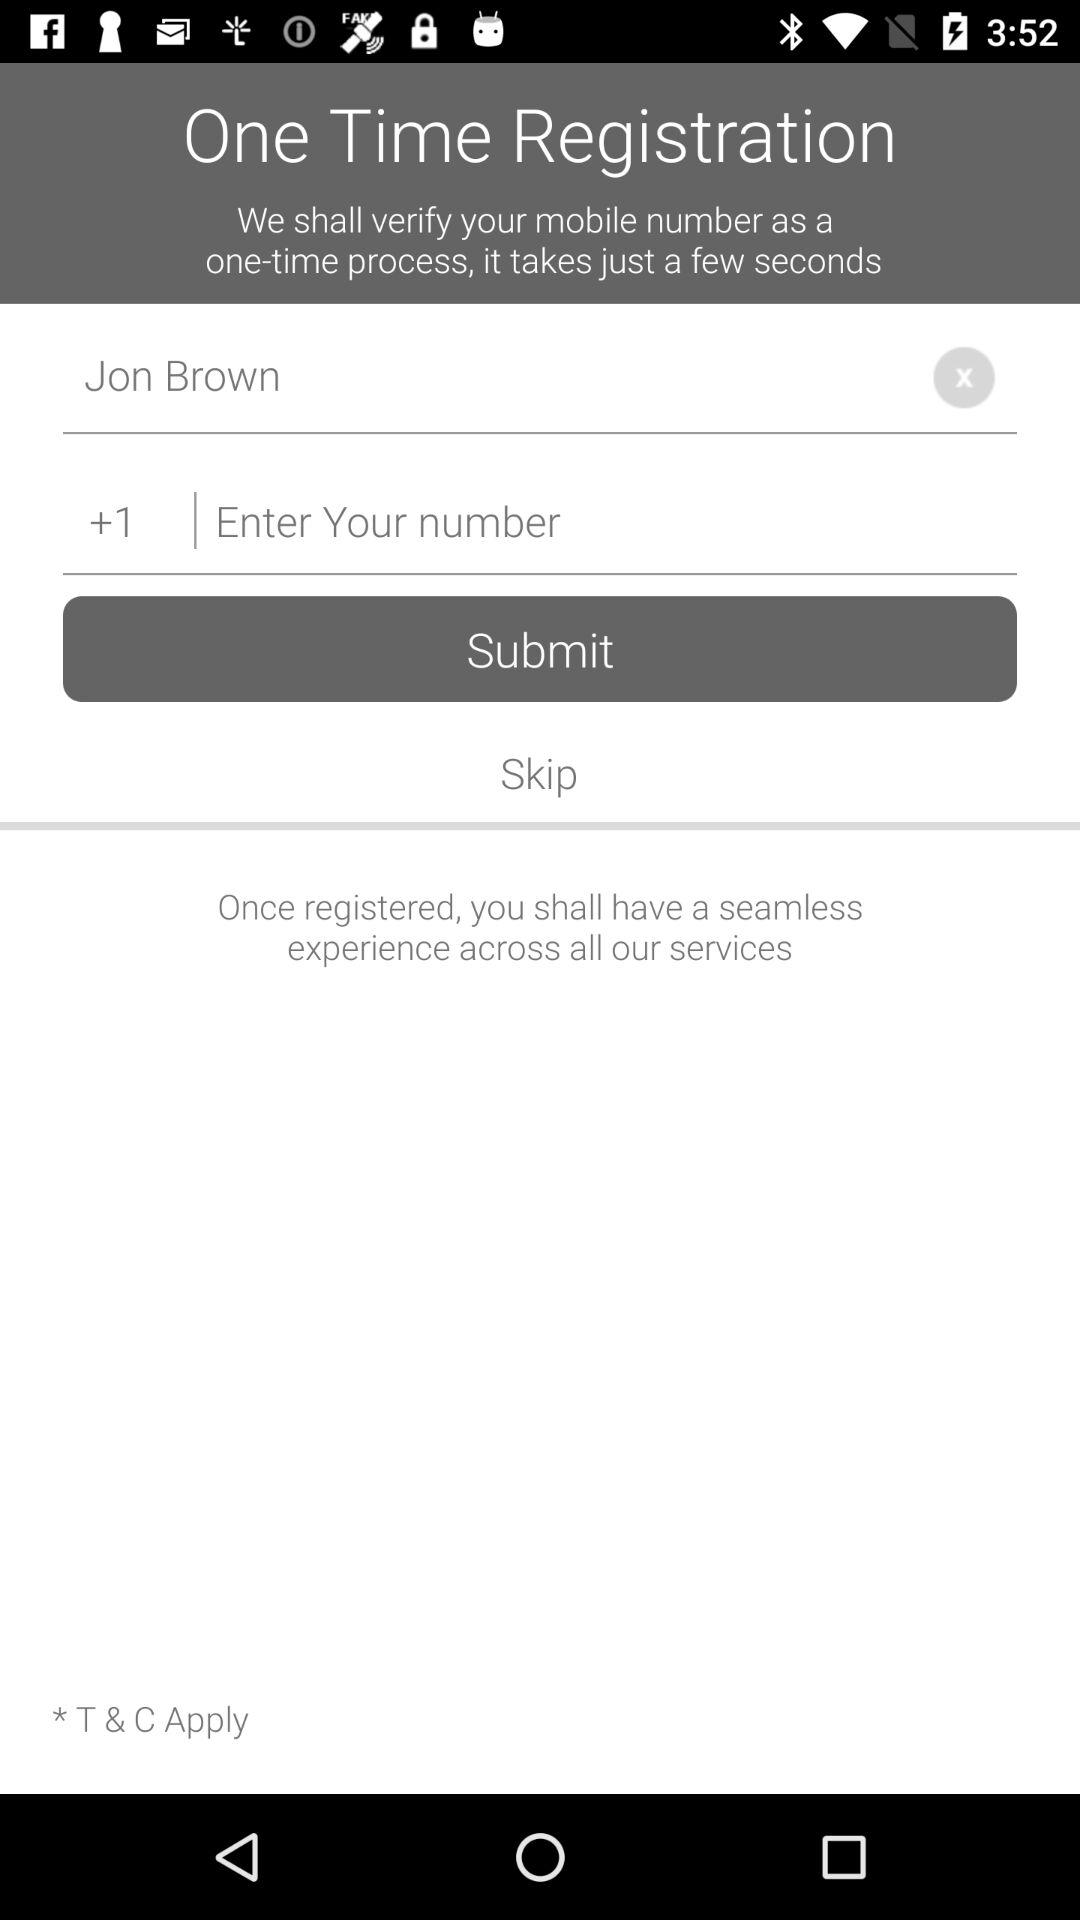What is the user name? The user name is Jon Brown. 